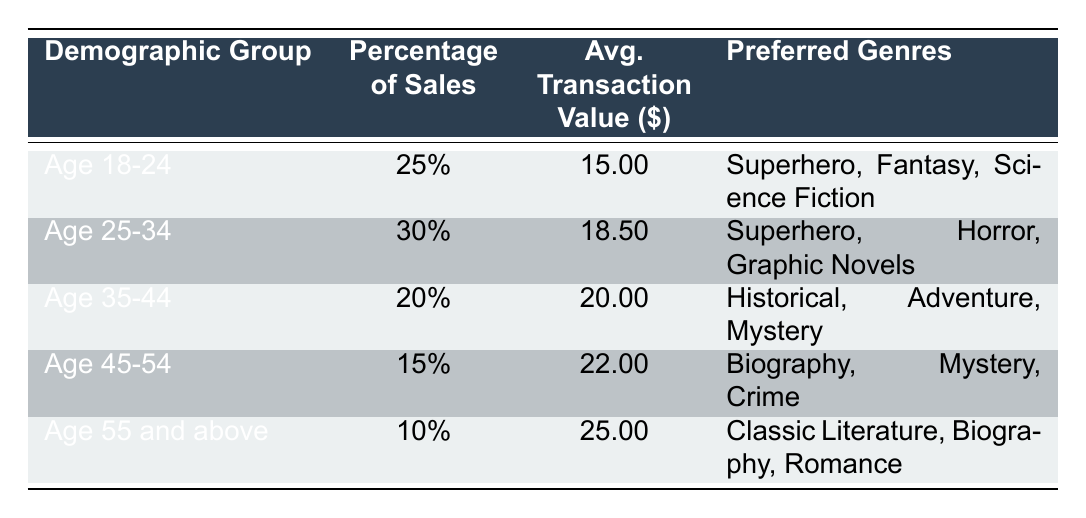What percentage of comic book sales comes from the Age 25-34 demographic group? The table shows that the percentage of sales for the Age 25-34 demographic group is explicitly listed under the "Percentage of Sales" column. For this group, it is 30%.
Answer: 30% What are the preferred genres of the Age 18-24 demographic group? The table includes a list of preferred genres for each demographic group. For the Age 18-24 group, the preferred genres are Superhero, Fantasy, and Science Fiction.
Answer: Superhero, Fantasy, Science Fiction Which age group has the highest average transaction value? To find the age group with the highest average transaction value, we compare the values in the "Avg. Transaction Value" column. The Age 55 and above demographic has the highest value at $25.00.
Answer: Age 55 and above Calculate the total percentage of comic book sales contributed by the Age 35-44 and Age 45-54 demographic groups combined. We add the percentages of both groups from the "Percentage of Sales" column: 20% (Age 35-44) + 15% (Age 45-54) = 35%.
Answer: 35% Is the average transaction value for the Age 55 and above demographic greater than $20.00? The average transaction value for the Age 55 and above demographic is $25.00. Since $25.00 is greater than $20.00, the answer is yes.
Answer: Yes How many demographic groups have a percentage of sales lower than 20%? By reviewing the "Percentage of Sales" column, we find that two groups (Age 45-54 at 15% and Age 55 and above at 10%) have percentages below 20%. Counting these gives us 2 groups.
Answer: 2 What is the difference in average transaction value between the Age 25-34 and Age 45-54 demographic groups? The average transaction value for Age 25-34 is $18.50, and for Age 45-54 it is $22.00. Subtracting these values, we find $22.00 - $18.50 = $3.50.
Answer: $3.50 Are the preferred genres for the Age 35-44 group also preferred by the Age 25-34 group? The preferred genres for Age 35-44 are Historical, Adventure, and Mystery. For Age 25-34, they are Superhero, Horror, and Graphic Novels. Since there are no common genres listed for both groups, the answer is no.
Answer: No 